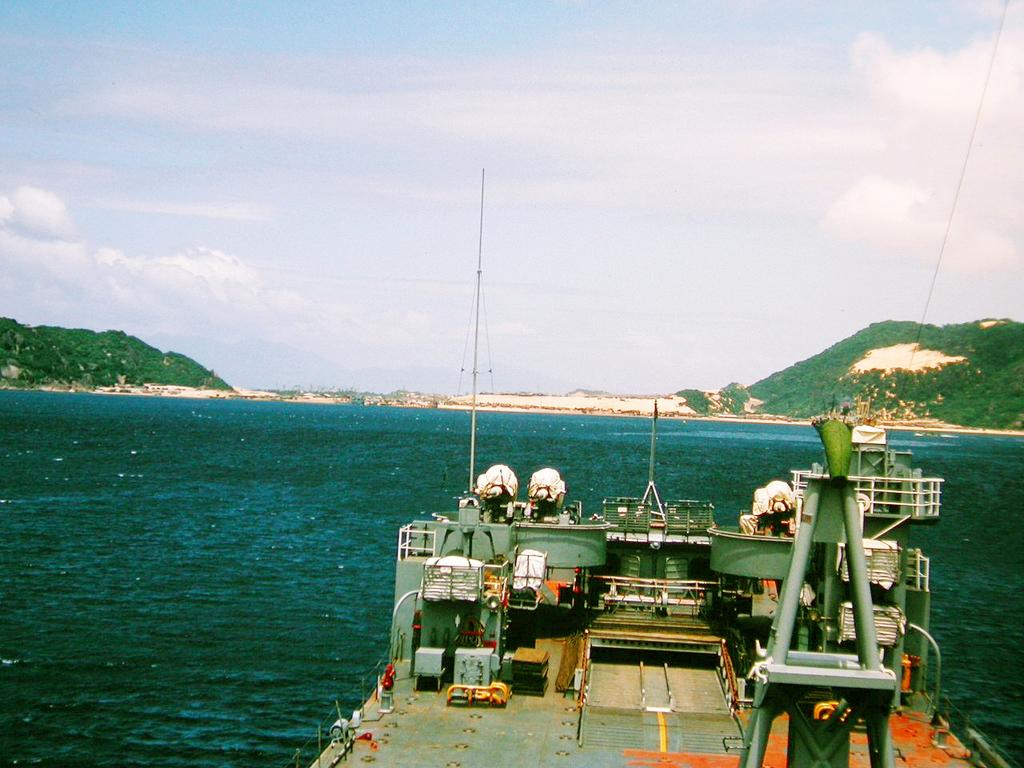What is the main subject of the image? The main subject of the image is a ship. Where is the ship located? The ship is present in the sea. What other natural features can be seen in the image? There are mountains with trees in the image. What is visible at the top of the image? The sky is visible at the top of the image. What can be observed in the sky? There are clouds in the sky. What type of cherry is being used as a word in the image? There is no cherry or word present in the image; it features a ship in the sea with mountains, trees, and clouds in the sky. 